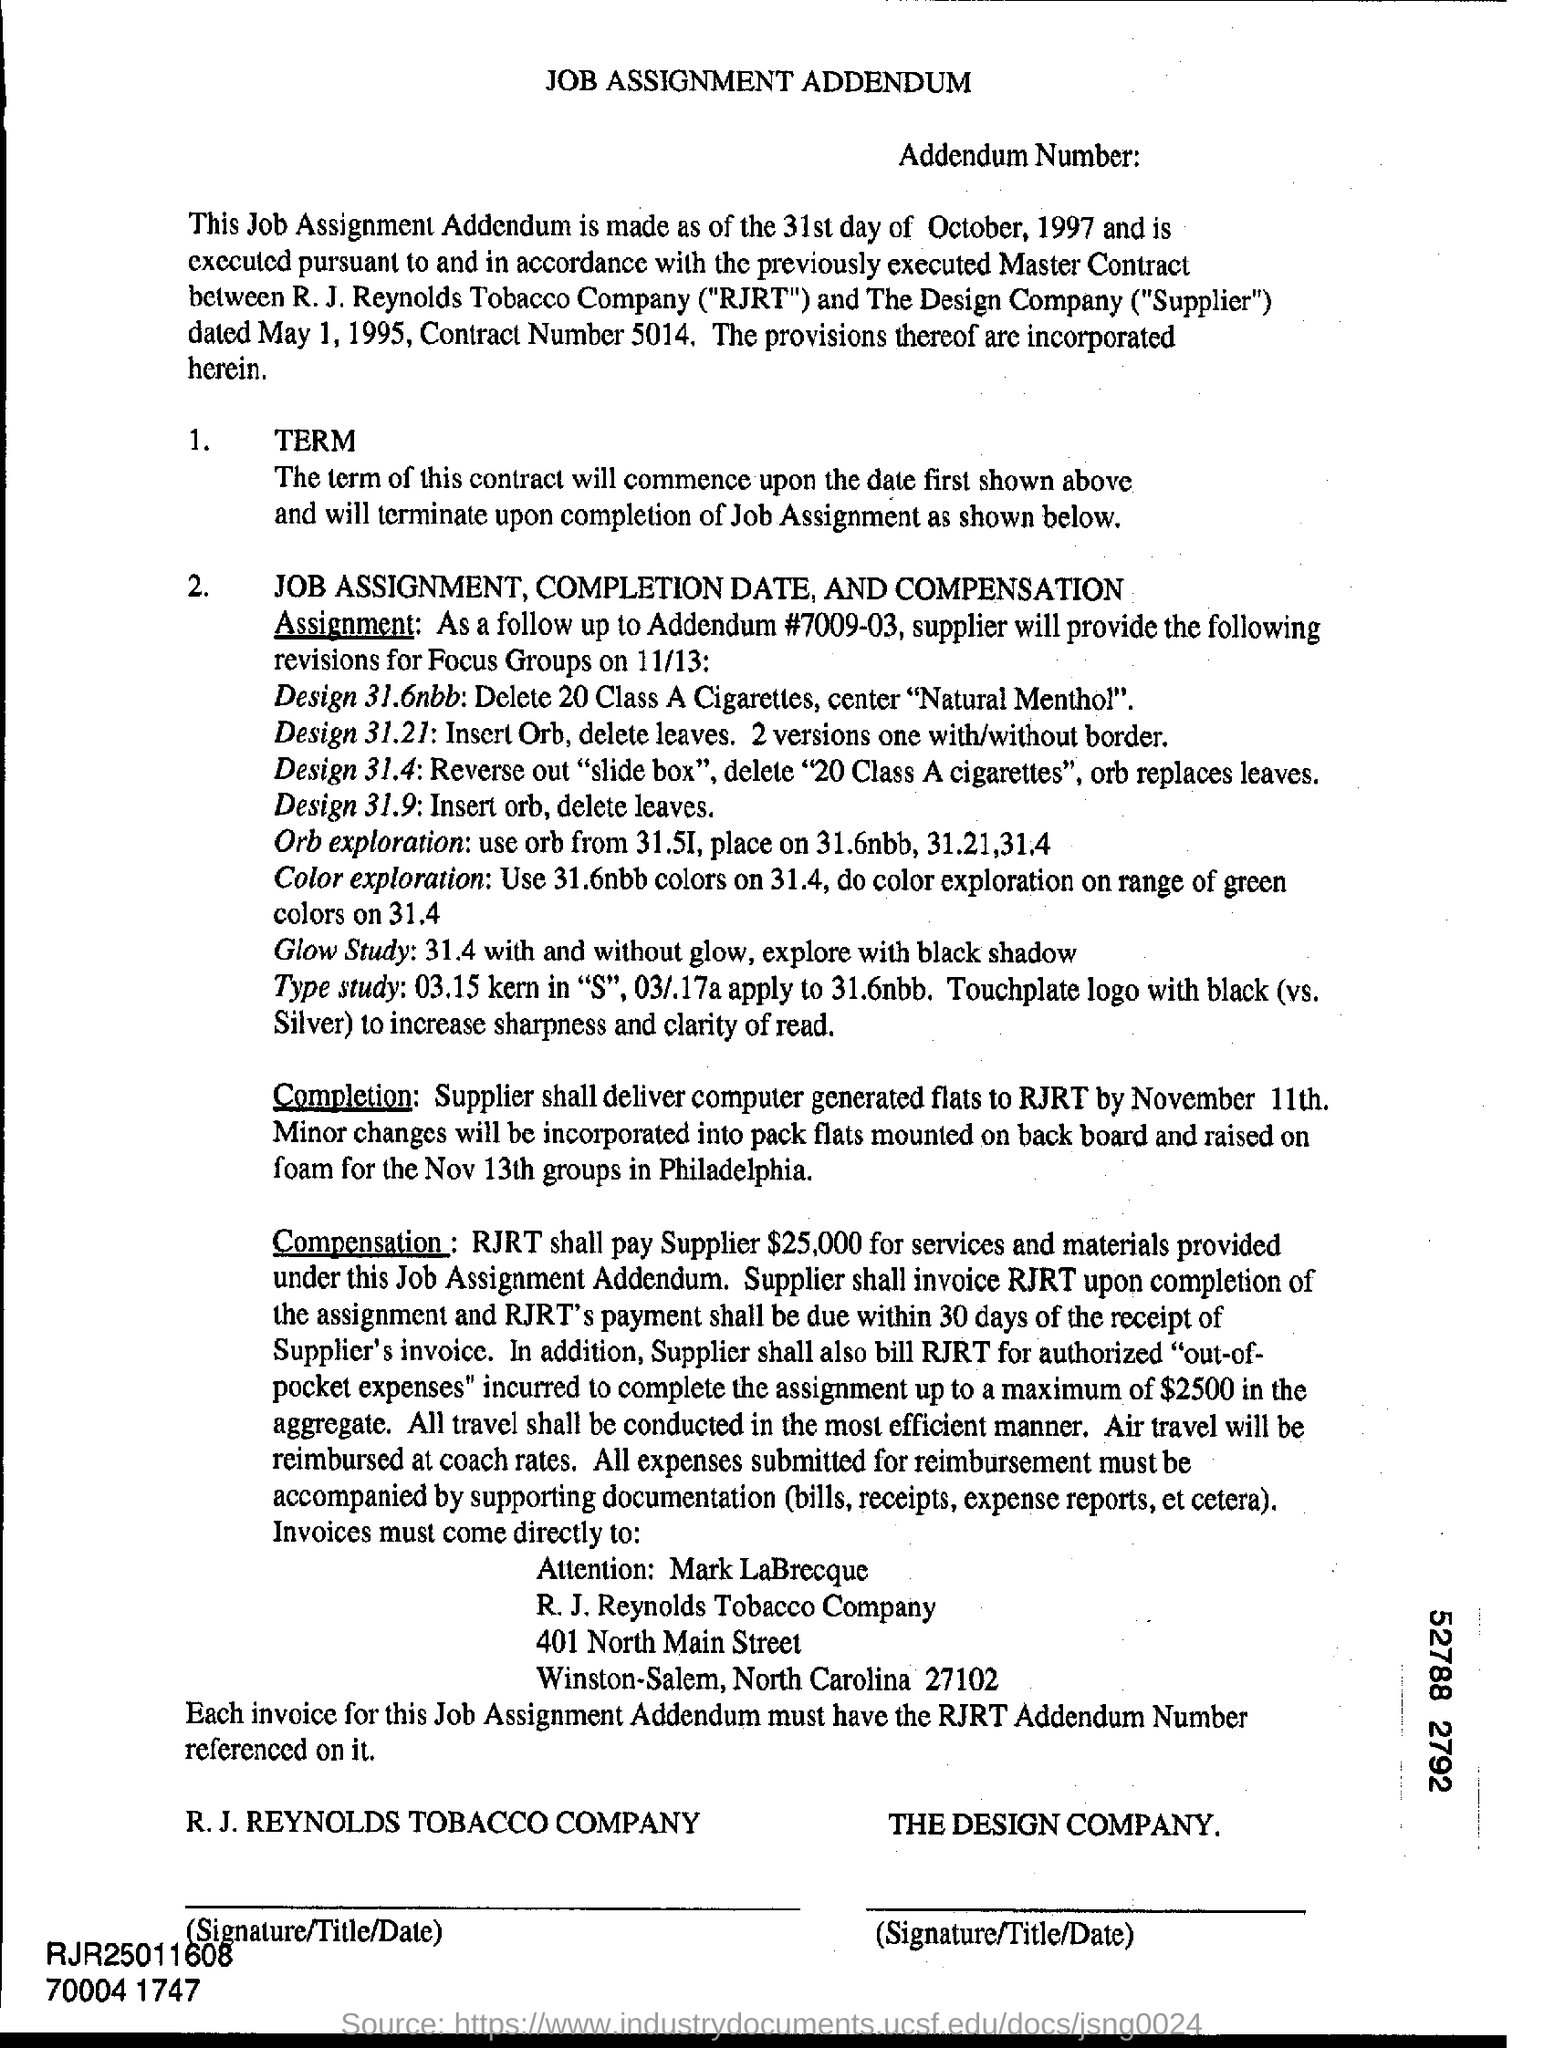Give some essential details in this illustration. The acronym "RJRT" stands for "R.J. Reynolds Tobacco Company. R.J. Reynolds Tobacco Company is located in the state of North Carolina. The design company is the supplier. The supplier shall be paid a total of $25,000 for services and materials provided under this job assignment addendum, as determined by RJRT. 